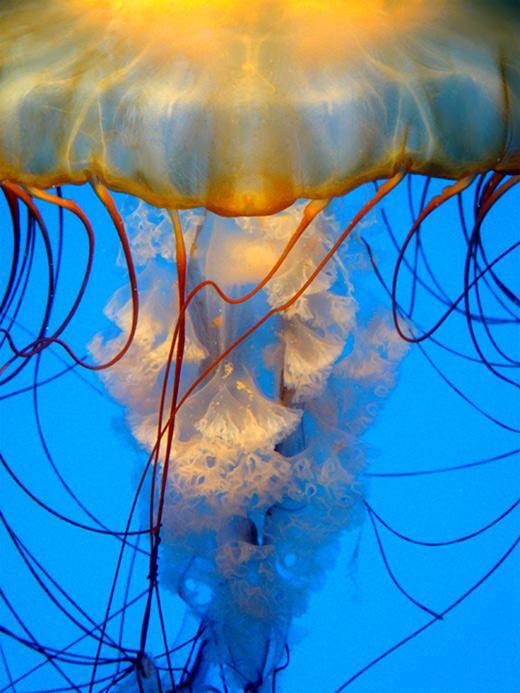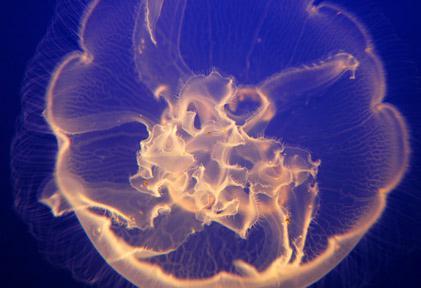The first image is the image on the left, the second image is the image on the right. Examine the images to the left and right. Is the description "The jellyfish in the image to the left has a distinct clover type image visible within its body." accurate? Answer yes or no. No. The first image is the image on the left, the second image is the image on the right. Analyze the images presented: Is the assertion "the jellyfish in the left image is swimming to the right" valid? Answer yes or no. No. 